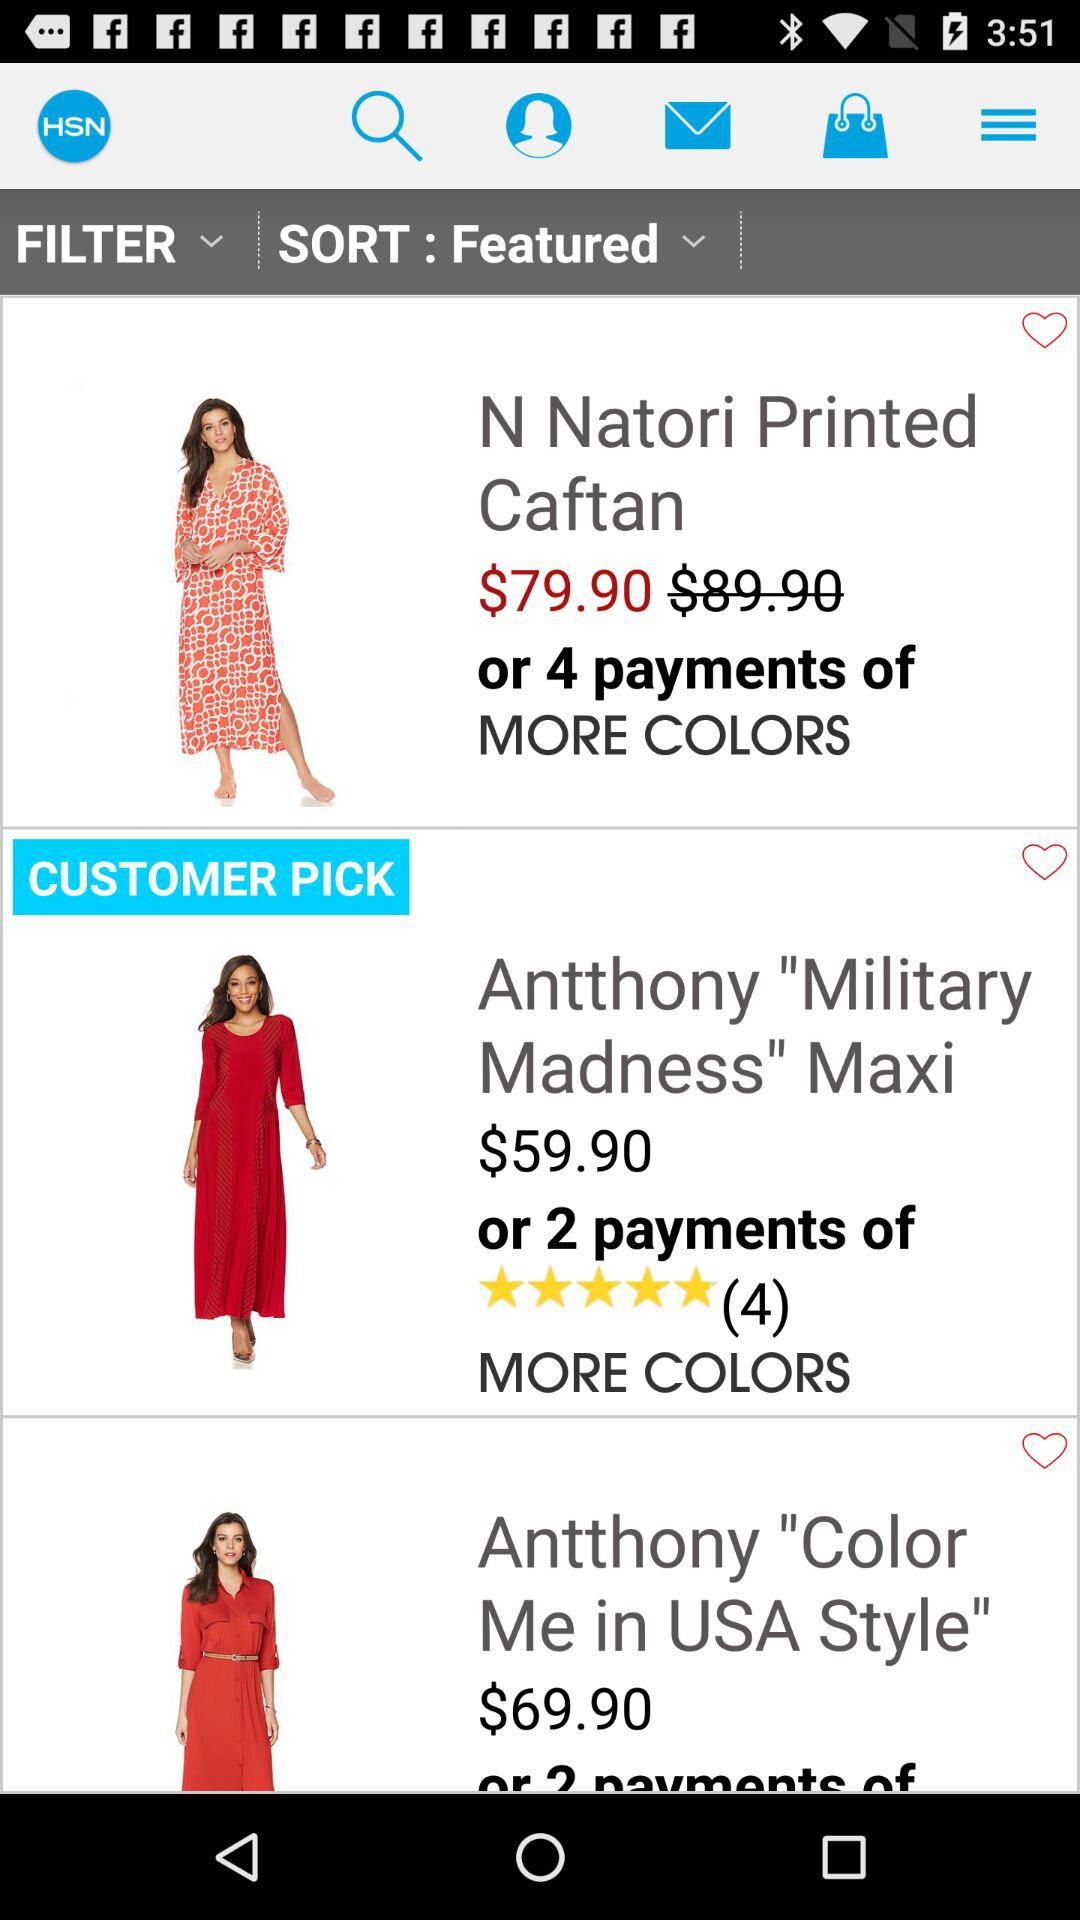What is the star rating of "Antthony "Military Madness" Maxi"? The star rating of "Antthony "Military Madness" Maxi" is 5 stars. 